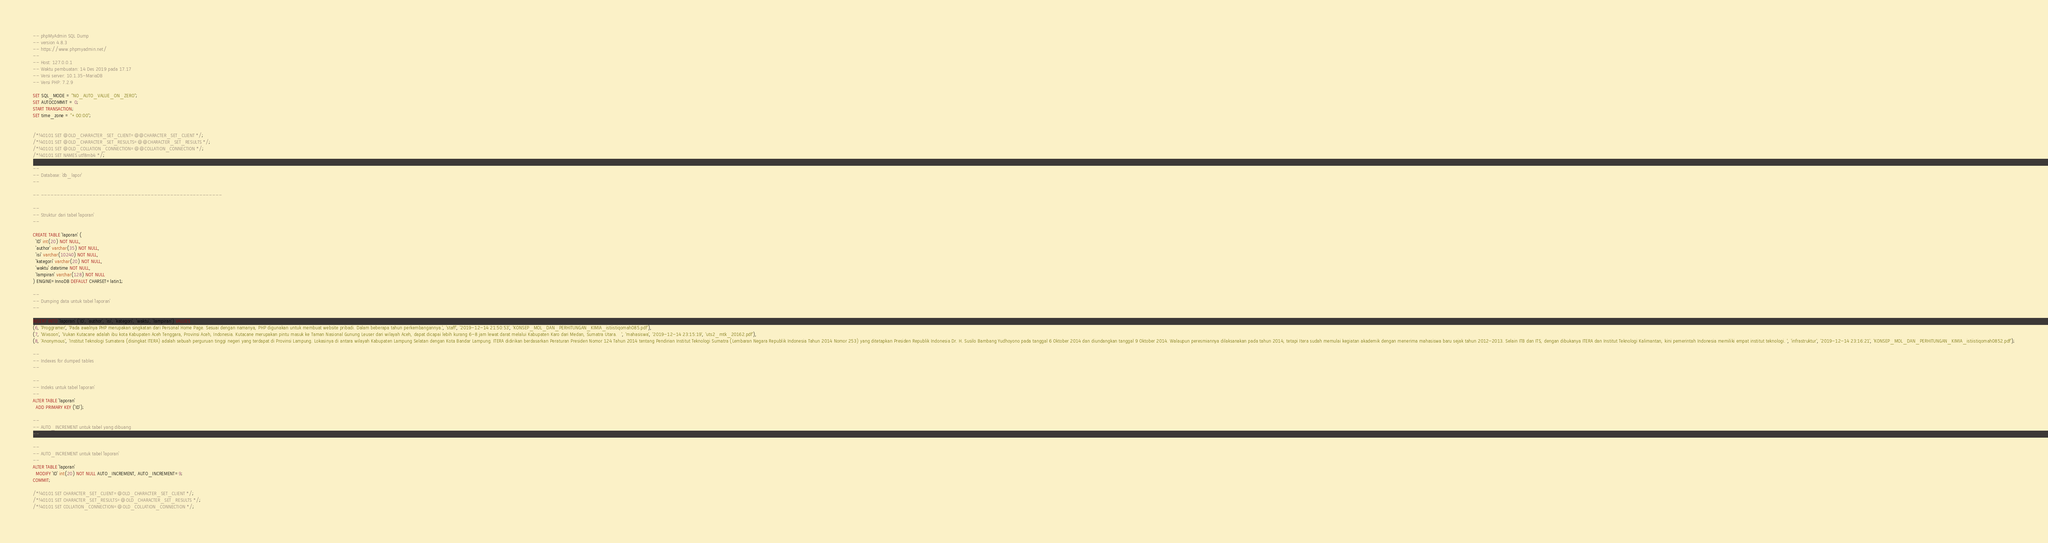<code> <loc_0><loc_0><loc_500><loc_500><_SQL_>-- phpMyAdmin SQL Dump
-- version 4.8.3
-- https://www.phpmyadmin.net/
--
-- Host: 127.0.0.1
-- Waktu pembuatan: 14 Des 2019 pada 17.17
-- Versi server: 10.1.35-MariaDB
-- Versi PHP: 7.2.9

SET SQL_MODE = "NO_AUTO_VALUE_ON_ZERO";
SET AUTOCOMMIT = 0;
START TRANSACTION;
SET time_zone = "+00:00";


/*!40101 SET @OLD_CHARACTER_SET_CLIENT=@@CHARACTER_SET_CLIENT */;
/*!40101 SET @OLD_CHARACTER_SET_RESULTS=@@CHARACTER_SET_RESULTS */;
/*!40101 SET @OLD_COLLATION_CONNECTION=@@COLLATION_CONNECTION */;
/*!40101 SET NAMES utf8mb4 */;

--
-- Database: `db_lapor`
--

-- --------------------------------------------------------

--
-- Struktur dari tabel `laporan`
--

CREATE TABLE `laporan` (
  `ID` int(20) NOT NULL,
  `author` varchar(35) NOT NULL,
  `isi` varchar(10240) NOT NULL,
  `kategori` varchar(20) NOT NULL,
  `waktu` datetime NOT NULL,
  `lampiran` varchar(128) NOT NULL
) ENGINE=InnoDB DEFAULT CHARSET=latin1;

--
-- Dumping data untuk tabel `laporan`
--

INSERT INTO `laporan` (`ID`, `author`, `isi`, `kategori`, `waktu`, `lampiran`) VALUES
(6, 'Proggramer', 'Pada awalnya PHP merupakan singkatan dari Personal Home Page. Sesuai dengan namanya, PHP digunakan untuk membuat website pribadi. Dalam beberapa tahun perkembangannya.', 'staff', '2019-12-14 21:50:53', 'KONSEP_MOL_DAN_PERHITUNGAN_KIMIA_istiistiqomah085.pdf'),
(7, 'Wixsoon', 'Vukan Kutacane adalah ibu kota Kabupaten Aceh Tenggara, Provinsi Aceh, Indonesia. Kutacane merupakan pintu masuk ke Taman Nasional Gunung Leuser dari wilayah Aceh, dapat dicapai lebih kurang 6-8 jam lewat darat melalui Kabupaten Karo dari Medan, Sumatra Utara. 	', 'mahasiswa', '2019-12-14 23:15:19', 'uts2_mtk_20162.pdf'),
(8, 'Anonymous', 'Institut Teknologi Sumatera (disingkat ITERA) adalah sebuah perguruan tinggi negeri yang terdapat di Provinsi Lampung. Lokasinya di antara wilayah Kabupaten Lampung Selatan dengan Kota Bandar Lampung. ITERA didirikan berdasarkan Peraturan Presiden Nomor 124 Tahun 2014 tentang Pendirian Institut Teknologi Sumatra (Lembaran Negara Republik Indonesia Tahun 2014 Nomor 253) yang ditetapkan Presiden Republik Indonesia Dr. H. Susilo Bambang Yudhoyono pada tanggal 6 Oktober 2014 dan diundangkan tanggal 9 Oktober 2014. Walaupun peresmiannya dilaksanakan pada tahun 2014, tetapi Itera sudah memulai kegiatan akademik dengan menerima mahasiswa baru sejak tahun 2012-2013. Selain ITB dan ITS, dengan dibukanya ITERA dan Institut Teknologi Kalimantan, kini pemerintah Indonesia memiliki empat institut teknologi. ', 'infrastruktur', '2019-12-14 23:16:21', 'KONSEP_MOL_DAN_PERHITUNGAN_KIMIA_istiistiqomah0852.pdf');

--
-- Indexes for dumped tables
--

--
-- Indeks untuk tabel `laporan`
--
ALTER TABLE `laporan`
  ADD PRIMARY KEY (`ID`);

--
-- AUTO_INCREMENT untuk tabel yang dibuang
--

--
-- AUTO_INCREMENT untuk tabel `laporan`
--
ALTER TABLE `laporan`
  MODIFY `ID` int(20) NOT NULL AUTO_INCREMENT, AUTO_INCREMENT=9;
COMMIT;

/*!40101 SET CHARACTER_SET_CLIENT=@OLD_CHARACTER_SET_CLIENT */;
/*!40101 SET CHARACTER_SET_RESULTS=@OLD_CHARACTER_SET_RESULTS */;
/*!40101 SET COLLATION_CONNECTION=@OLD_COLLATION_CONNECTION */;
</code> 